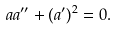Convert formula to latex. <formula><loc_0><loc_0><loc_500><loc_500>a a ^ { \prime \prime } + ( a ^ { \prime } ) ^ { 2 } = 0 .</formula> 